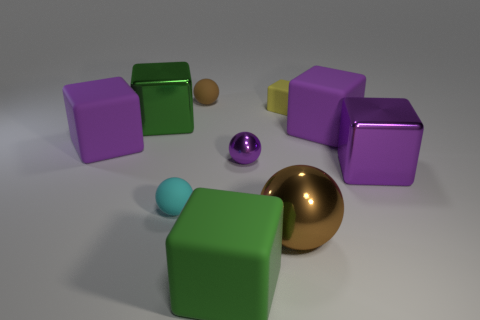There is a block on the right side of the big purple matte block that is on the right side of the brown thing that is in front of the yellow thing; what is its material?
Your answer should be compact. Metal. Are there any other things that have the same material as the big brown object?
Provide a short and direct response. Yes. There is a tiny matte object that is in front of the purple sphere; does it have the same color as the tiny cube?
Your answer should be very brief. No. How many brown objects are large matte things or metallic cubes?
Offer a very short reply. 0. How many other things are there of the same shape as the large green shiny thing?
Your answer should be very brief. 5. Is the material of the small block the same as the cyan ball?
Your answer should be very brief. Yes. There is a small object that is behind the large green shiny object and to the left of the small purple ball; what is its material?
Keep it short and to the point. Rubber. What color is the tiny matte sphere that is in front of the tiny matte cube?
Make the answer very short. Cyan. Is the number of small cyan balls behind the tiny yellow matte thing greater than the number of brown metallic balls?
Ensure brevity in your answer.  No. How many other things are there of the same size as the purple shiny block?
Your answer should be very brief. 5. 